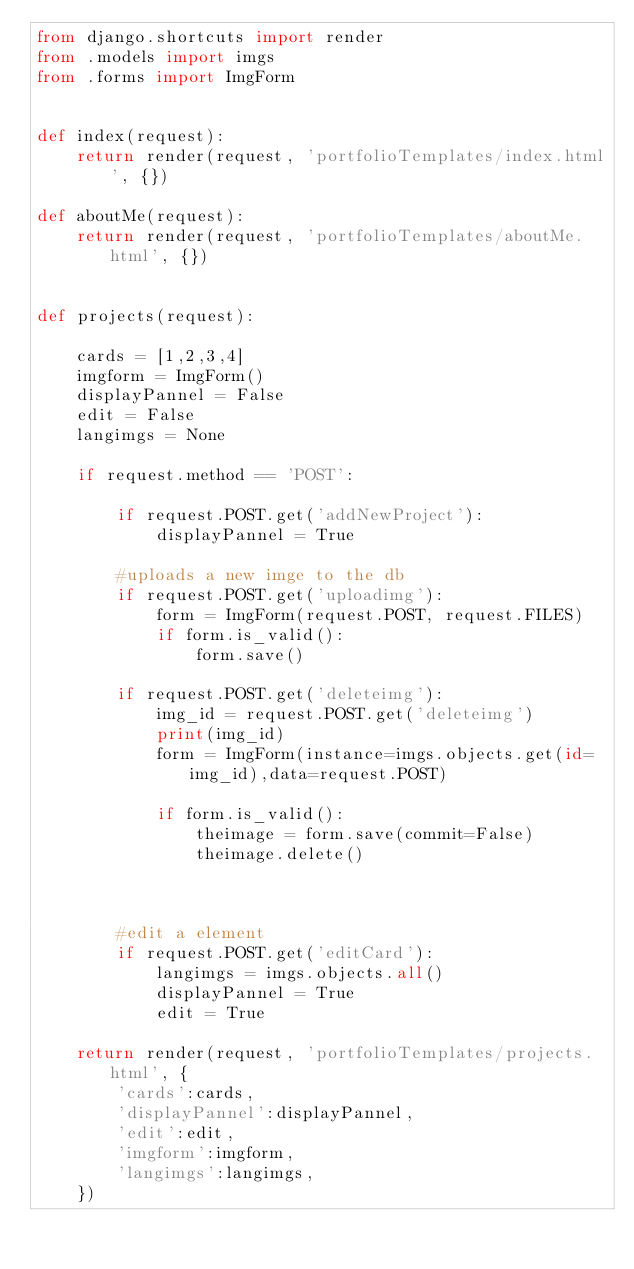Convert code to text. <code><loc_0><loc_0><loc_500><loc_500><_Python_>from django.shortcuts import render
from .models import imgs
from .forms import ImgForm


def index(request):
    return render(request, 'portfolioTemplates/index.html', {})

def aboutMe(request):
    return render(request, 'portfolioTemplates/aboutMe.html', {})


def projects(request):

    cards = [1,2,3,4]
    imgform = ImgForm()
    displayPannel = False
    edit = False
    langimgs = None

    if request.method == 'POST':

        if request.POST.get('addNewProject'):
            displayPannel = True
        
        #uploads a new imge to the db
        if request.POST.get('uploadimg'):
            form = ImgForm(request.POST, request.FILES)
            if form.is_valid():
                form.save()
        
        if request.POST.get('deleteimg'):
            img_id = request.POST.get('deleteimg')
            print(img_id)
            form = ImgForm(instance=imgs.objects.get(id=img_id),data=request.POST)

            if form.is_valid():
                theimage = form.save(commit=False)
                theimage.delete()



        #edit a element
        if request.POST.get('editCard'):
            langimgs = imgs.objects.all()
            displayPannel = True
            edit = True

    return render(request, 'portfolioTemplates/projects.html', {
        'cards':cards,
        'displayPannel':displayPannel,
        'edit':edit,
        'imgform':imgform,
        'langimgs':langimgs,
    })</code> 